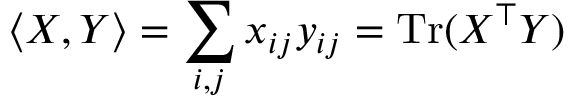Convert formula to latex. <formula><loc_0><loc_0><loc_500><loc_500>\langle X , Y \rangle = \sum _ { i , j } x _ { i j } y _ { i j } = T r ( X ^ { \top } Y )</formula> 